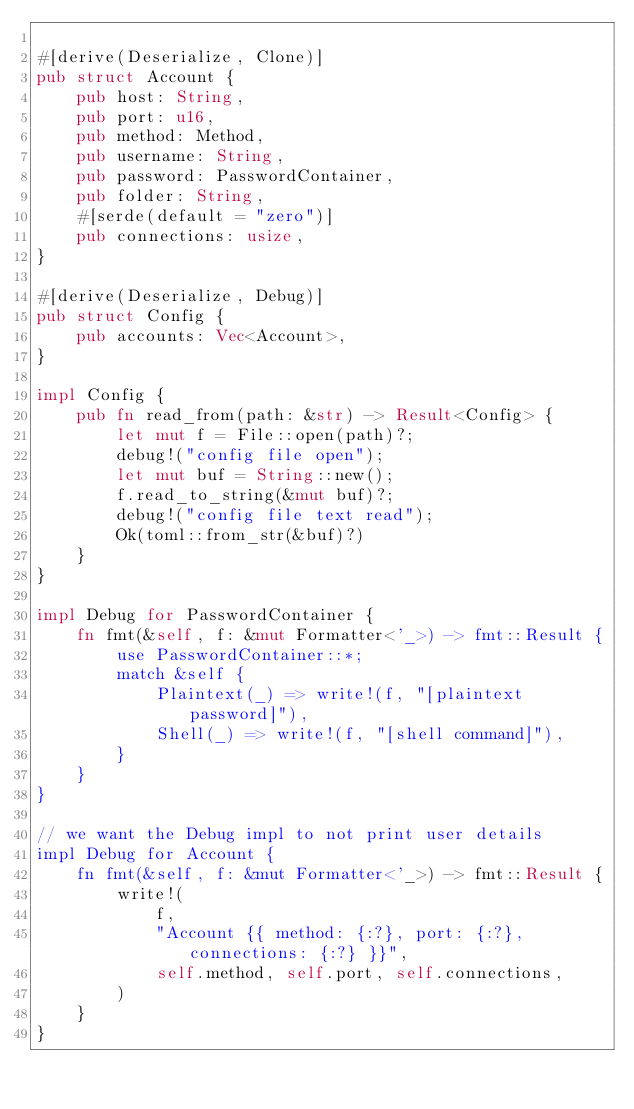Convert code to text. <code><loc_0><loc_0><loc_500><loc_500><_Rust_>
#[derive(Deserialize, Clone)]
pub struct Account {
    pub host: String,
    pub port: u16,
    pub method: Method,
    pub username: String,
    pub password: PasswordContainer,
    pub folder: String,
    #[serde(default = "zero")]
    pub connections: usize,
}

#[derive(Deserialize, Debug)]
pub struct Config {
    pub accounts: Vec<Account>,
}

impl Config {
    pub fn read_from(path: &str) -> Result<Config> {
        let mut f = File::open(path)?;
        debug!("config file open");
        let mut buf = String::new();
        f.read_to_string(&mut buf)?;
        debug!("config file text read");
        Ok(toml::from_str(&buf)?)
    }
}

impl Debug for PasswordContainer {
    fn fmt(&self, f: &mut Formatter<'_>) -> fmt::Result {
        use PasswordContainer::*;
        match &self {
            Plaintext(_) => write!(f, "[plaintext password]"),
            Shell(_) => write!(f, "[shell command]"),
        }
    }
}

// we want the Debug impl to not print user details
impl Debug for Account {
    fn fmt(&self, f: &mut Formatter<'_>) -> fmt::Result {
        write!(
            f,
            "Account {{ method: {:?}, port: {:?}, connections: {:?} }}",
            self.method, self.port, self.connections,
        )
    }
}
</code> 